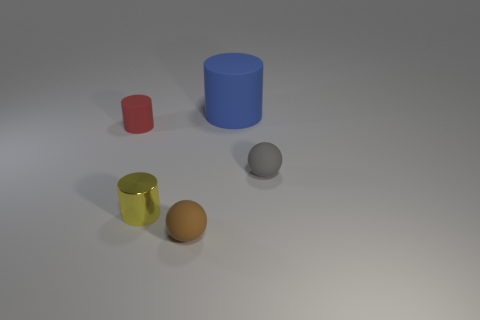How many objects are either tiny gray rubber balls or small rubber spheres that are left of the large object?
Give a very brief answer. 2. Is there a red thing that has the same shape as the tiny yellow metallic thing?
Provide a short and direct response. Yes. Are there the same number of tiny matte cylinders in front of the small metal cylinder and blue rubber objects to the left of the red object?
Make the answer very short. Yes. Is there any other thing that has the same size as the blue object?
Your answer should be very brief. No. What number of gray objects are either small rubber spheres or large shiny cylinders?
Your answer should be very brief. 1. How many other matte objects are the same size as the gray matte object?
Offer a terse response. 2. What is the color of the tiny thing that is both left of the brown rubber thing and behind the metallic object?
Your answer should be compact. Red. Are there more metal cylinders left of the small metallic thing than brown rubber things?
Give a very brief answer. No. Are any tiny yellow cylinders visible?
Ensure brevity in your answer.  Yes. Is the color of the tiny metal cylinder the same as the big rubber thing?
Provide a short and direct response. No. 